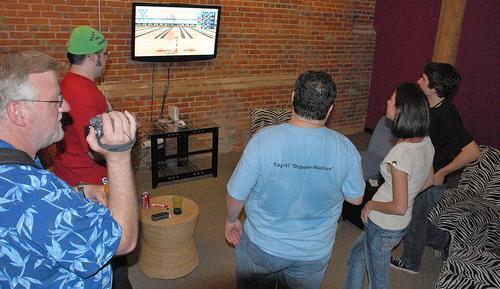How many people?
Give a very brief answer. 5. How many green hats?
Give a very brief answer. 1. 